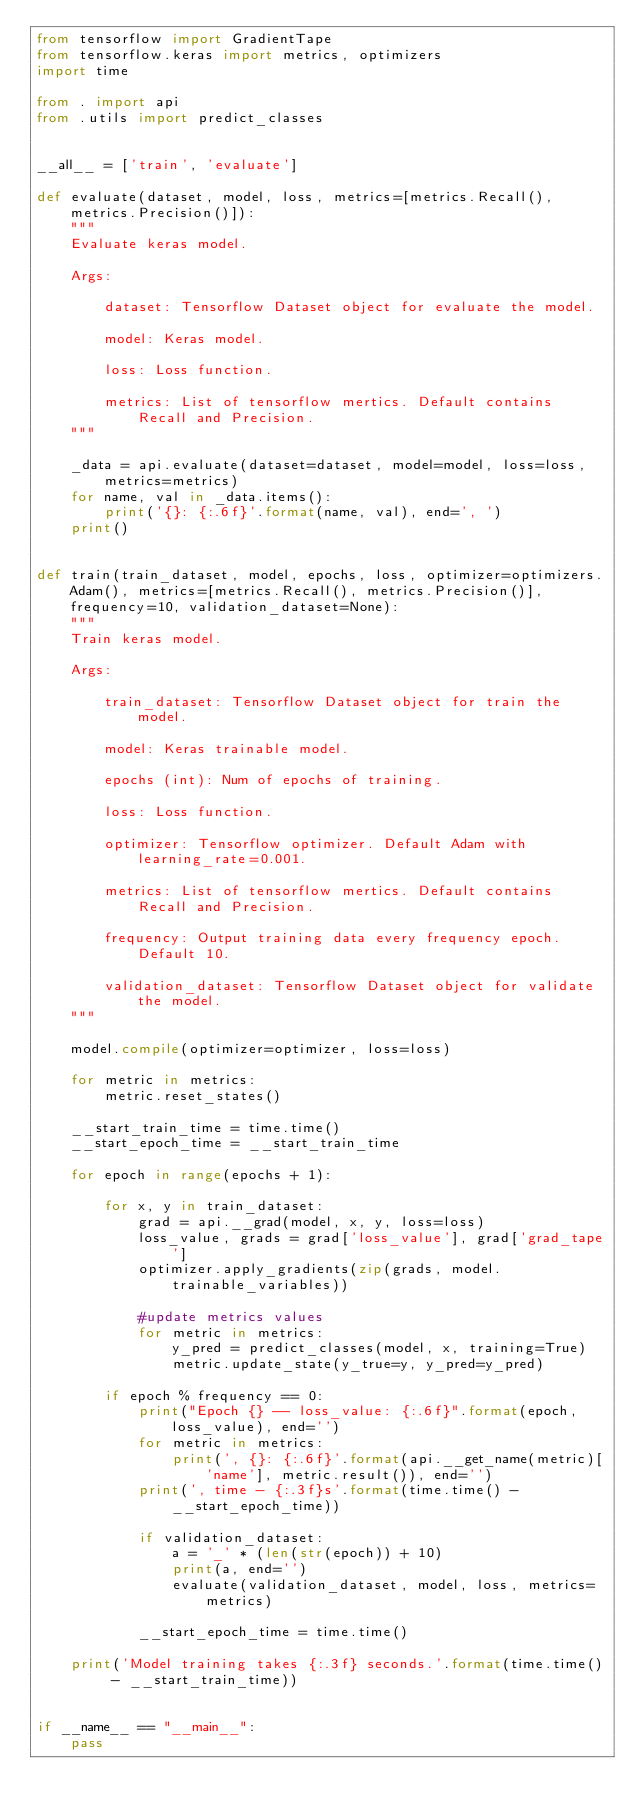<code> <loc_0><loc_0><loc_500><loc_500><_Python_>from tensorflow import GradientTape
from tensorflow.keras import metrics, optimizers
import time

from . import api
from .utils import predict_classes


__all__ = ['train', 'evaluate']

def evaluate(dataset, model, loss, metrics=[metrics.Recall(), metrics.Precision()]):
    """
    Evaluate keras model.

    Args:
    
        dataset: Tensorflow Dataset object for evaluate the model.

        model: Keras model.

        loss: Loss function.

        metrics: List of tensorflow mertics. Default contains Recall and Precision.
    """

    _data = api.evaluate(dataset=dataset, model=model, loss=loss, metrics=metrics)
    for name, val in _data.items():
        print('{}: {:.6f}'.format(name, val), end=', ')
    print()


def train(train_dataset, model, epochs, loss, optimizer=optimizers.Adam(), metrics=[metrics.Recall(), metrics.Precision()], frequency=10, validation_dataset=None):
    """
    Train keras model.

    Args:
    
        train_dataset: Tensorflow Dataset object for train the model.

        model: Keras trainable model.

        epochs (int): Num of epochs of training.

        loss: Loss function.

        optimizer: Tensorflow optimizer. Default Adam with learning_rate=0.001.

        metrics: List of tensorflow mertics. Default contains Recall and Precision.

        frequency: Output training data every frequency epoch. Default 10.

        validation_dataset: Tensorflow Dataset object for validate the model.
    """

    model.compile(optimizer=optimizer, loss=loss)

    for metric in metrics:
        metric.reset_states()

    __start_train_time = time.time()
    __start_epoch_time = __start_train_time

    for epoch in range(epochs + 1):

        for x, y in train_dataset:
            grad = api.__grad(model, x, y, loss=loss)
            loss_value, grads = grad['loss_value'], grad['grad_tape']
            optimizer.apply_gradients(zip(grads, model.trainable_variables))

            #update metrics values
            for metric in metrics:
                y_pred = predict_classes(model, x, training=True)
                metric.update_state(y_true=y, y_pred=y_pred)

        if epoch % frequency == 0:
            print("Epoch {} -- loss_value: {:.6f}".format(epoch, loss_value), end='')
            for metric in metrics:
                print(', {}: {:.6f}'.format(api.__get_name(metric)['name'], metric.result()), end='')
            print(', time - {:.3f}s'.format(time.time() - __start_epoch_time))

            if validation_dataset:
                a = '_' * (len(str(epoch)) + 10)
                print(a, end='')
                evaluate(validation_dataset, model, loss, metrics=metrics)

            __start_epoch_time = time.time()

    print('Model training takes {:.3f} seconds.'.format(time.time() - __start_train_time))

            
if __name__ == "__main__":
    pass
</code> 